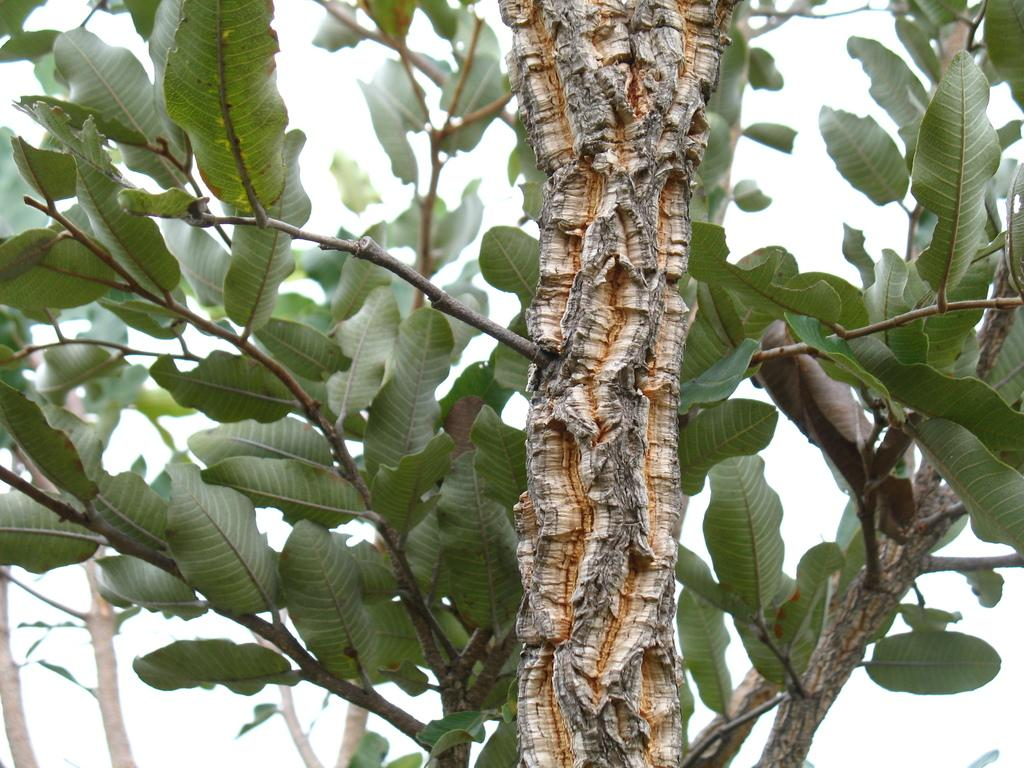What type of plant can be seen in the image? There is a tree in the image. What type of knee can be seen resting near the lake in the image? There is no knee, rest, or lake present in the image; it only features a tree. 